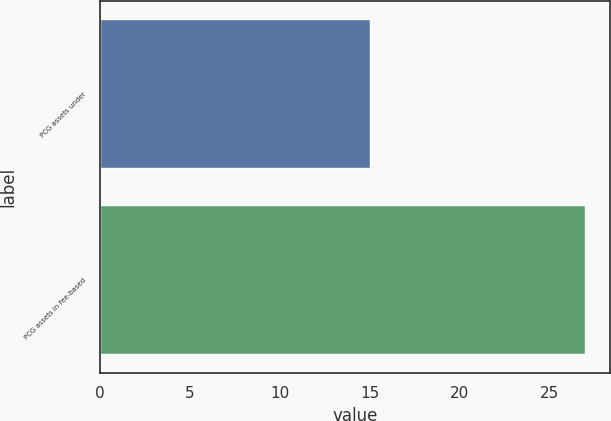Convert chart. <chart><loc_0><loc_0><loc_500><loc_500><bar_chart><fcel>PCG assets under<fcel>PCG assets in fee-based<nl><fcel>15<fcel>27<nl></chart> 